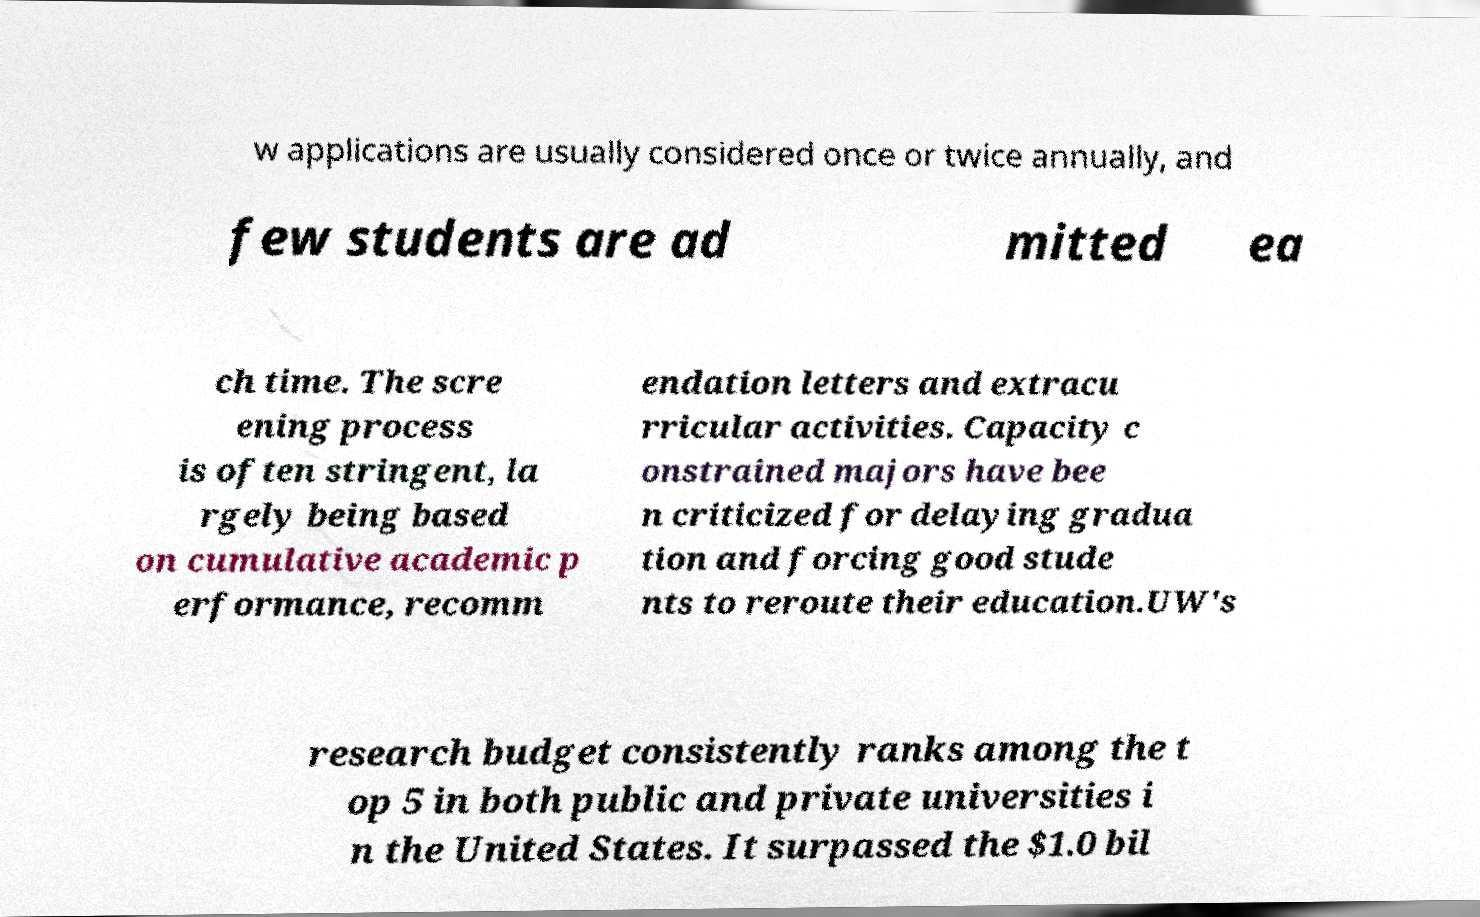Can you read and provide the text displayed in the image?This photo seems to have some interesting text. Can you extract and type it out for me? w applications are usually considered once or twice annually, and few students are ad mitted ea ch time. The scre ening process is often stringent, la rgely being based on cumulative academic p erformance, recomm endation letters and extracu rricular activities. Capacity c onstrained majors have bee n criticized for delaying gradua tion and forcing good stude nts to reroute their education.UW's research budget consistently ranks among the t op 5 in both public and private universities i n the United States. It surpassed the $1.0 bil 